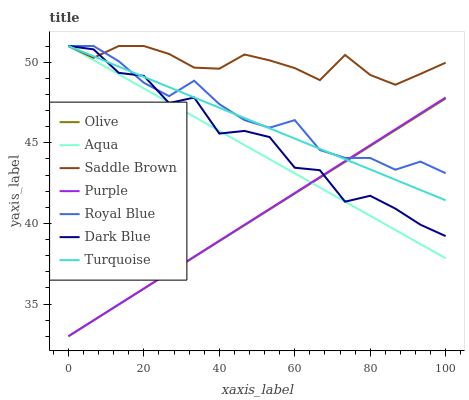Does Olive have the minimum area under the curve?
Answer yes or no. Yes. Does Saddle Brown have the maximum area under the curve?
Answer yes or no. Yes. Does Royal Blue have the minimum area under the curve?
Answer yes or no. No. Does Royal Blue have the maximum area under the curve?
Answer yes or no. No. Is Olive the smoothest?
Answer yes or no. Yes. Is Dark Blue the roughest?
Answer yes or no. Yes. Is Royal Blue the smoothest?
Answer yes or no. No. Is Royal Blue the roughest?
Answer yes or no. No. Does Purple have the lowest value?
Answer yes or no. Yes. Does Royal Blue have the lowest value?
Answer yes or no. No. Does Saddle Brown have the highest value?
Answer yes or no. Yes. Does Purple have the highest value?
Answer yes or no. No. Is Purple less than Saddle Brown?
Answer yes or no. Yes. Is Saddle Brown greater than Olive?
Answer yes or no. Yes. Does Aqua intersect Dark Blue?
Answer yes or no. Yes. Is Aqua less than Dark Blue?
Answer yes or no. No. Is Aqua greater than Dark Blue?
Answer yes or no. No. Does Purple intersect Saddle Brown?
Answer yes or no. No. 